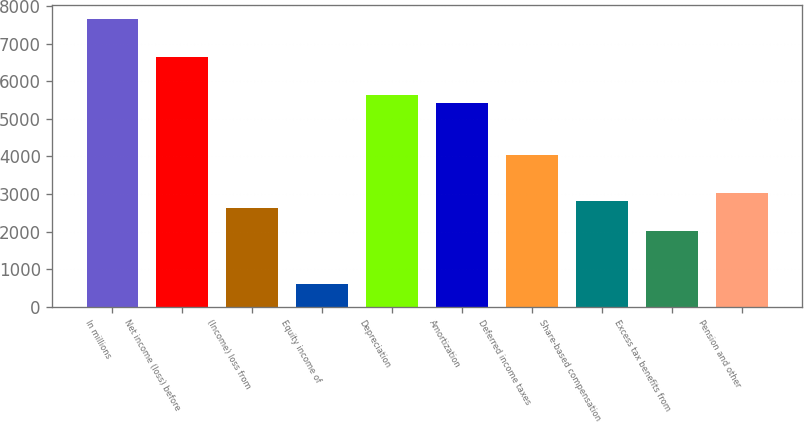Convert chart. <chart><loc_0><loc_0><loc_500><loc_500><bar_chart><fcel>In millions<fcel>Net income (loss) before<fcel>(Income) loss from<fcel>Equity income of<fcel>Depreciation<fcel>Amortization<fcel>Deferred income taxes<fcel>Share-based compensation<fcel>Excess tax benefits from<fcel>Pension and other<nl><fcel>7647.44<fcel>6641.29<fcel>2616.69<fcel>604.39<fcel>5635.14<fcel>5433.91<fcel>4025.3<fcel>2817.92<fcel>2013<fcel>3019.15<nl></chart> 